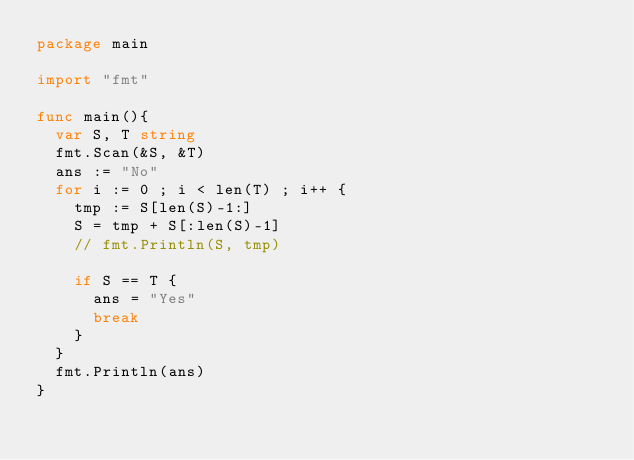<code> <loc_0><loc_0><loc_500><loc_500><_Go_>package main

import "fmt"

func main(){
	var S, T string
	fmt.Scan(&S, &T)
	ans := "No"
	for i := 0 ; i < len(T) ; i++ {
		tmp := S[len(S)-1:]
		S = tmp + S[:len(S)-1]
		// fmt.Println(S, tmp)

		if S == T {
			ans = "Yes"
			break
		}
	}
	fmt.Println(ans)
}</code> 